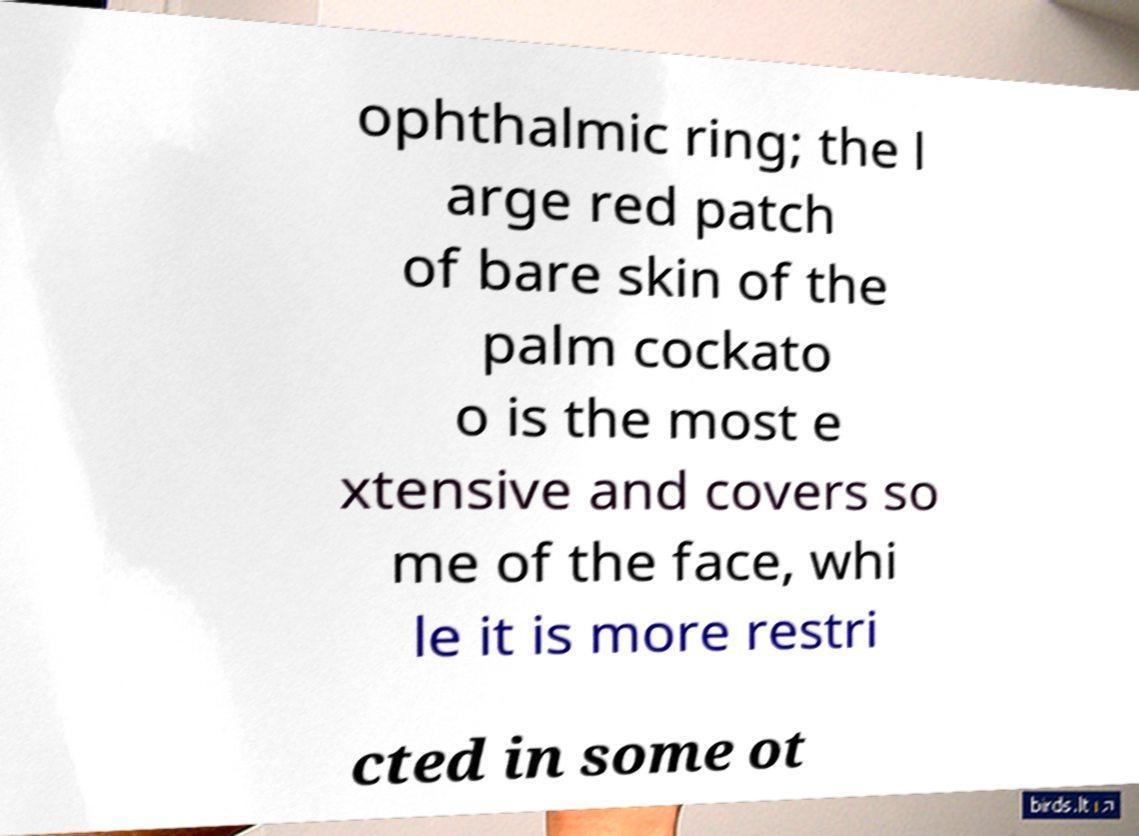What messages or text are displayed in this image? I need them in a readable, typed format. ophthalmic ring; the l arge red patch of bare skin of the palm cockato o is the most e xtensive and covers so me of the face, whi le it is more restri cted in some ot 